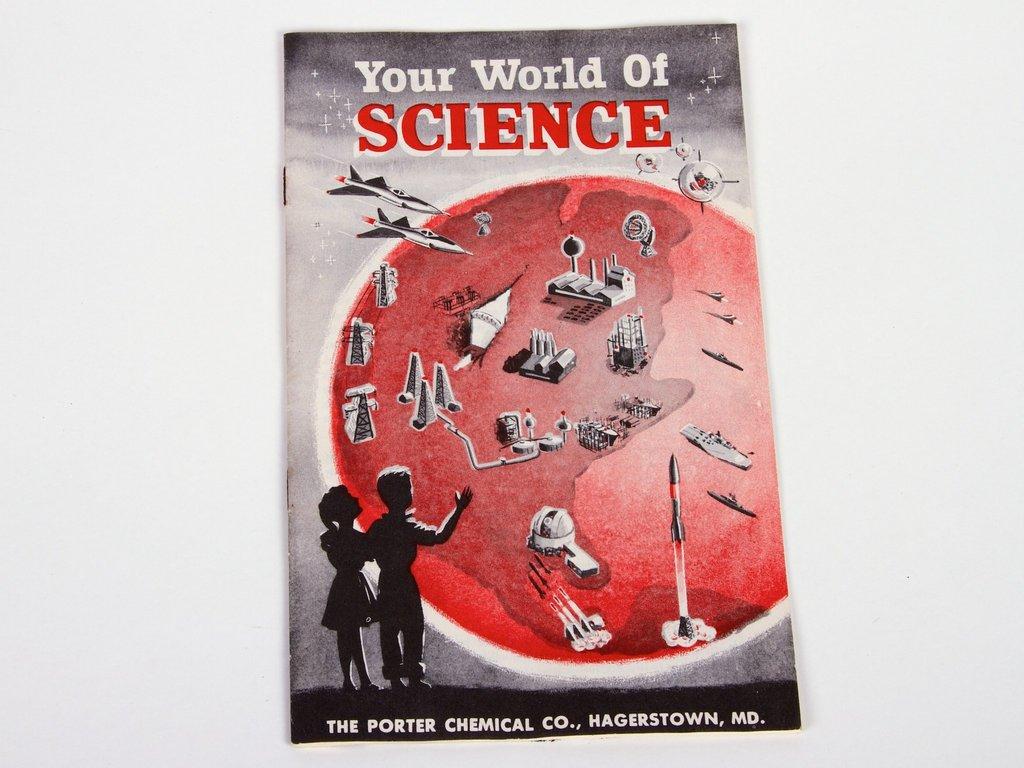Is this science book for kids?
Your response must be concise. Yes. Where was this book published?
Keep it short and to the point. Hagerstown, md. 